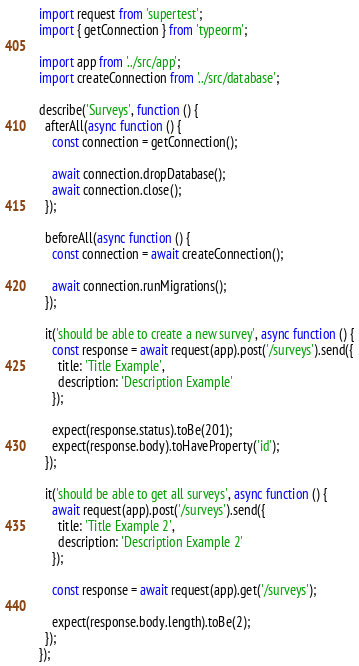Convert code to text. <code><loc_0><loc_0><loc_500><loc_500><_TypeScript_>import request from 'supertest';
import { getConnection } from 'typeorm';

import app from '../src/app';
import createConnection from '../src/database';

describe('Surveys', function () {
  afterAll(async function () {
    const connection = getConnection();

    await connection.dropDatabase();
    await connection.close();
  });

  beforeAll(async function () {
    const connection = await createConnection();

    await connection.runMigrations();
  });

  it('should be able to create a new survey', async function () {
    const response = await request(app).post('/surveys').send({
      title: 'Title Example',
      description: 'Description Example'
    });

    expect(response.status).toBe(201);
    expect(response.body).toHaveProperty('id');
  });

  it('should be able to get all surveys', async function () {
    await request(app).post('/surveys').send({
      title: 'Title Example 2',
      description: 'Description Example 2'
    });

    const response = await request(app).get('/surveys');

    expect(response.body.length).toBe(2);
  });
});
</code> 